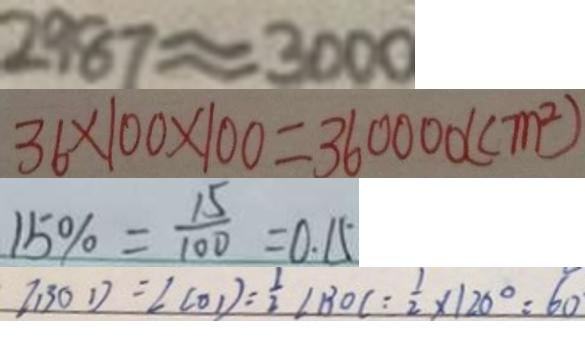Convert formula to latex. <formula><loc_0><loc_0><loc_500><loc_500>2 9 8 7 \approx 3 0 0 0 
 3 6 \times 1 0 0 \times 1 0 0 = 3 6 0 0 0 0 ( c m ^ { 2 } ) 
 1 5 \% = \frac { 1 5 } { 1 0 0 } = 0 . 1 5 
 \angle B O D = \angle C O D = \frac { 1 } { 2 } \angle B O C = \frac { 1 } { 2 } \times 1 2 0 ^ { \circ } = 6 0</formula> 